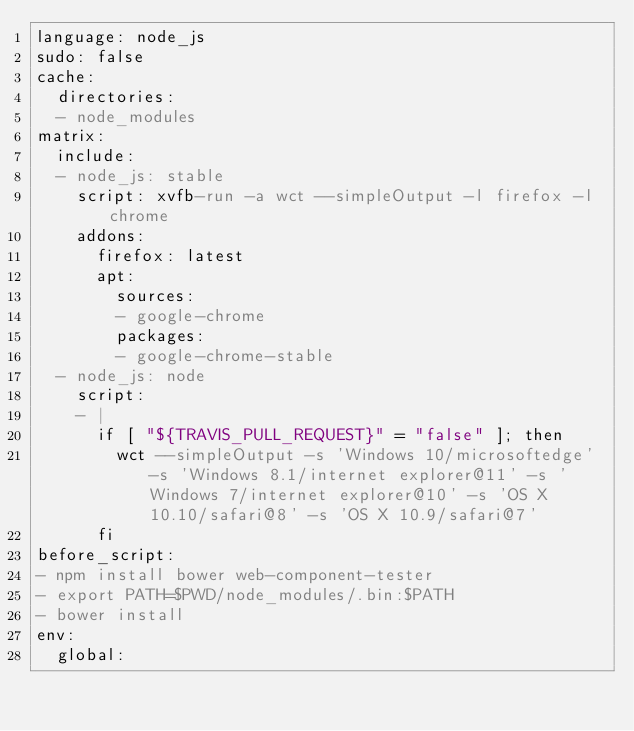<code> <loc_0><loc_0><loc_500><loc_500><_YAML_>language: node_js
sudo: false
cache:
  directories:
  - node_modules
matrix:
  include:
  - node_js: stable
    script: xvfb-run -a wct --simpleOutput -l firefox -l chrome
    addons:
      firefox: latest
      apt:
        sources:
        - google-chrome
        packages:
        - google-chrome-stable
  - node_js: node
    script:
    - |
      if [ "${TRAVIS_PULL_REQUEST}" = "false" ]; then
        wct --simpleOutput -s 'Windows 10/microsoftedge' -s 'Windows 8.1/internet explorer@11' -s 'Windows 7/internet explorer@10' -s 'OS X 10.10/safari@8' -s 'OS X 10.9/safari@7'
      fi
before_script:
- npm install bower web-component-tester
- export PATH=$PWD/node_modules/.bin:$PATH
- bower install
env:
  global:</code> 